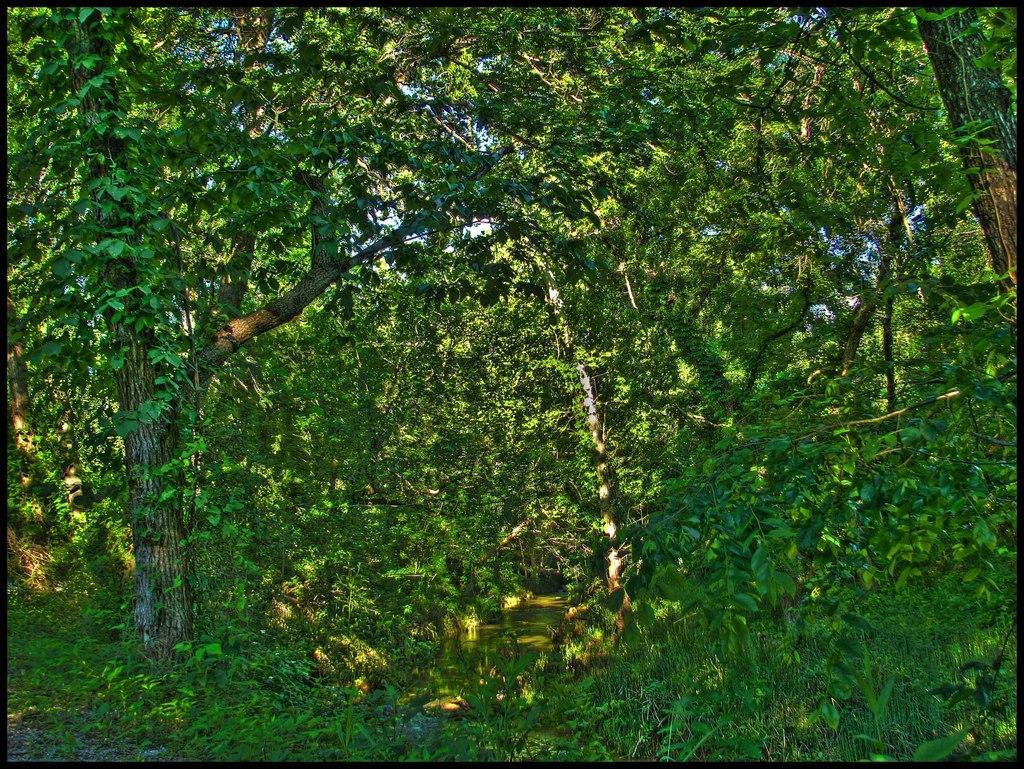Please provide a concise description of this image. In this picture there is greenery around the area of the image. 